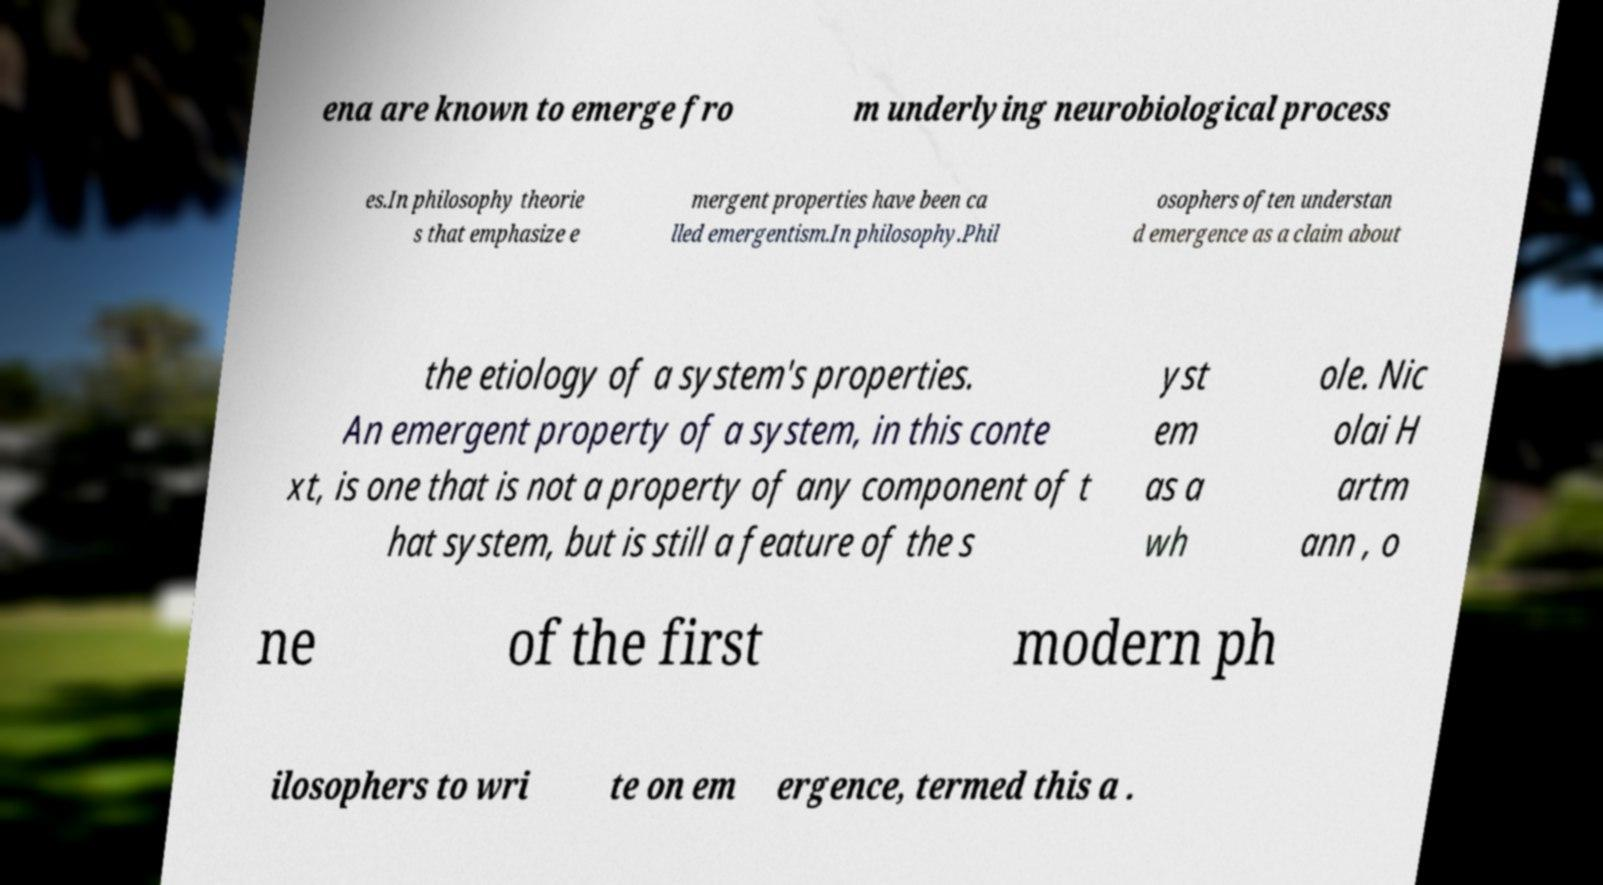There's text embedded in this image that I need extracted. Can you transcribe it verbatim? ena are known to emerge fro m underlying neurobiological process es.In philosophy theorie s that emphasize e mergent properties have been ca lled emergentism.In philosophy.Phil osophers often understan d emergence as a claim about the etiology of a system's properties. An emergent property of a system, in this conte xt, is one that is not a property of any component of t hat system, but is still a feature of the s yst em as a wh ole. Nic olai H artm ann , o ne of the first modern ph ilosophers to wri te on em ergence, termed this a . 